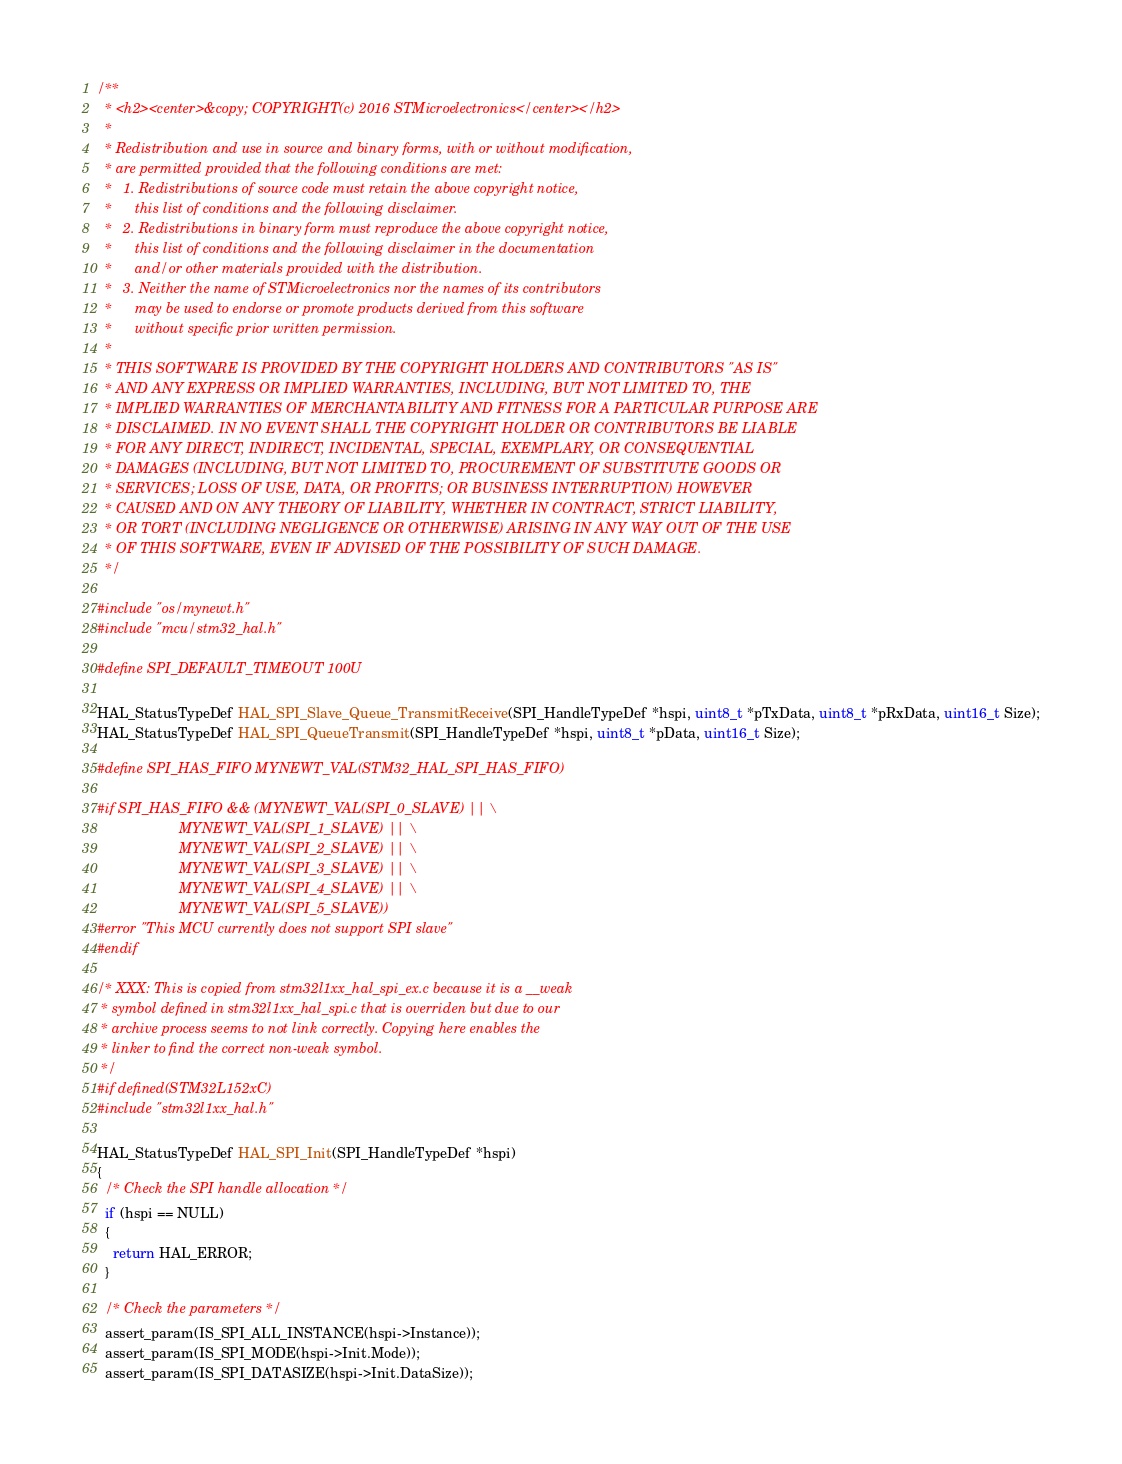<code> <loc_0><loc_0><loc_500><loc_500><_C_>/**
  * <h2><center>&copy; COPYRIGHT(c) 2016 STMicroelectronics</center></h2>
  *
  * Redistribution and use in source and binary forms, with or without modification,
  * are permitted provided that the following conditions are met:
  *   1. Redistributions of source code must retain the above copyright notice,
  *      this list of conditions and the following disclaimer.
  *   2. Redistributions in binary form must reproduce the above copyright notice,
  *      this list of conditions and the following disclaimer in the documentation
  *      and/or other materials provided with the distribution.
  *   3. Neither the name of STMicroelectronics nor the names of its contributors
  *      may be used to endorse or promote products derived from this software
  *      without specific prior written permission.
  *
  * THIS SOFTWARE IS PROVIDED BY THE COPYRIGHT HOLDERS AND CONTRIBUTORS "AS IS"
  * AND ANY EXPRESS OR IMPLIED WARRANTIES, INCLUDING, BUT NOT LIMITED TO, THE
  * IMPLIED WARRANTIES OF MERCHANTABILITY AND FITNESS FOR A PARTICULAR PURPOSE ARE
  * DISCLAIMED. IN NO EVENT SHALL THE COPYRIGHT HOLDER OR CONTRIBUTORS BE LIABLE
  * FOR ANY DIRECT, INDIRECT, INCIDENTAL, SPECIAL, EXEMPLARY, OR CONSEQUENTIAL
  * DAMAGES (INCLUDING, BUT NOT LIMITED TO, PROCUREMENT OF SUBSTITUTE GOODS OR
  * SERVICES; LOSS OF USE, DATA, OR PROFITS; OR BUSINESS INTERRUPTION) HOWEVER
  * CAUSED AND ON ANY THEORY OF LIABILITY, WHETHER IN CONTRACT, STRICT LIABILITY,
  * OR TORT (INCLUDING NEGLIGENCE OR OTHERWISE) ARISING IN ANY WAY OUT OF THE USE
  * OF THIS SOFTWARE, EVEN IF ADVISED OF THE POSSIBILITY OF SUCH DAMAGE.
  */

#include "os/mynewt.h"
#include "mcu/stm32_hal.h"

#define SPI_DEFAULT_TIMEOUT 100U

HAL_StatusTypeDef HAL_SPI_Slave_Queue_TransmitReceive(SPI_HandleTypeDef *hspi, uint8_t *pTxData, uint8_t *pRxData, uint16_t Size);
HAL_StatusTypeDef HAL_SPI_QueueTransmit(SPI_HandleTypeDef *hspi, uint8_t *pData, uint16_t Size);

#define SPI_HAS_FIFO MYNEWT_VAL(STM32_HAL_SPI_HAS_FIFO)

#if SPI_HAS_FIFO && (MYNEWT_VAL(SPI_0_SLAVE) || \
                     MYNEWT_VAL(SPI_1_SLAVE) || \
                     MYNEWT_VAL(SPI_2_SLAVE) || \
                     MYNEWT_VAL(SPI_3_SLAVE) || \
                     MYNEWT_VAL(SPI_4_SLAVE) || \
                     MYNEWT_VAL(SPI_5_SLAVE))
#error "This MCU currently does not support SPI slave"
#endif

/* XXX: This is copied from stm32l1xx_hal_spi_ex.c because it is a __weak
 * symbol defined in stm32l1xx_hal_spi.c that is overriden but due to our
 * archive process seems to not link correctly. Copying here enables the
 * linker to find the correct non-weak symbol.
 */
#if defined(STM32L152xC)
#include "stm32l1xx_hal.h"

HAL_StatusTypeDef HAL_SPI_Init(SPI_HandleTypeDef *hspi)
{
  /* Check the SPI handle allocation */
  if (hspi == NULL)
  {
    return HAL_ERROR;
  }

  /* Check the parameters */
  assert_param(IS_SPI_ALL_INSTANCE(hspi->Instance));
  assert_param(IS_SPI_MODE(hspi->Init.Mode));
  assert_param(IS_SPI_DATASIZE(hspi->Init.DataSize));</code> 